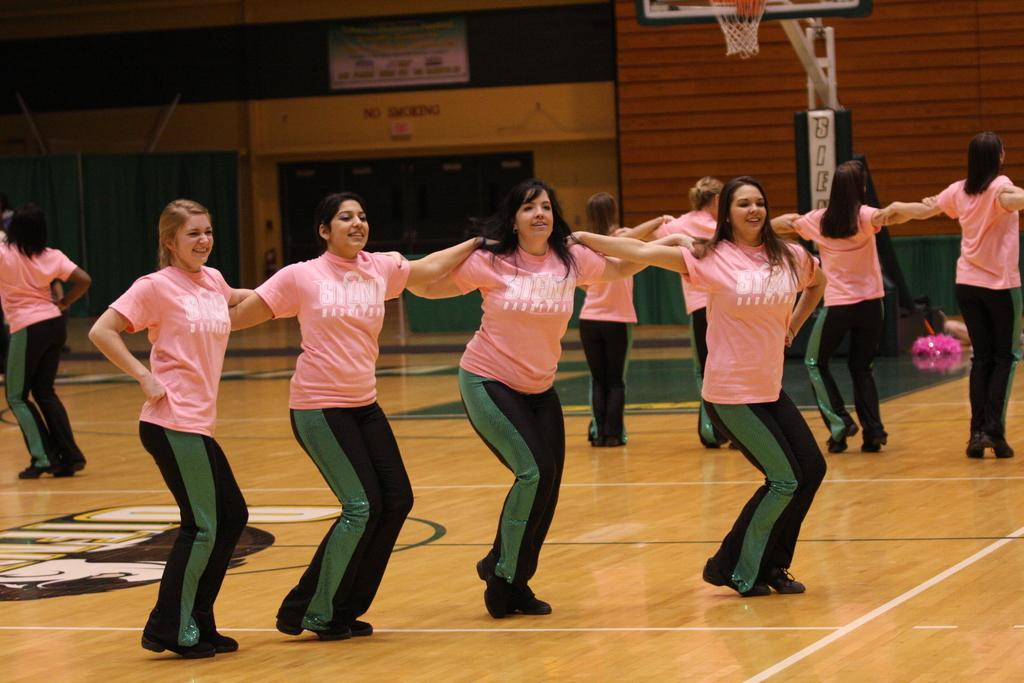What is the main subject of the image? The main subject of the image is a group of women. How are the women positioned in the image? The women are standing together in the image. What color are the t-shirts worn by the women? The women are wearing pink t-shirts. What type of clothing are the women wearing on their lower bodies? The women are wearing pants. What type of footwear are the women wearing? The women are wearing shoes. What can be seen in the background of the image? There is a board and a basket in the background of the image. How many men are present in the image? There are no men present in the image; it features a group of women. What type of dinosaur can be seen interacting with the women in the image? There are no dinosaurs present in the image; it features a group of women standing together. 